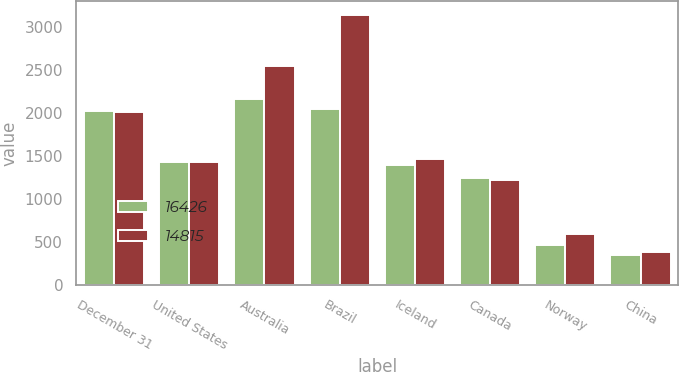Convert chart. <chart><loc_0><loc_0><loc_500><loc_500><stacked_bar_chart><ecel><fcel>December 31<fcel>United States<fcel>Australia<fcel>Brazil<fcel>Iceland<fcel>Canada<fcel>Norway<fcel>China<nl><fcel>16426<fcel>2015<fcel>1428.5<fcel>2159<fcel>2046<fcel>1397<fcel>1238<fcel>463<fcel>352<nl><fcel>14815<fcel>2014<fcel>1428.5<fcel>2538<fcel>3137<fcel>1460<fcel>1216<fcel>588<fcel>389<nl></chart> 